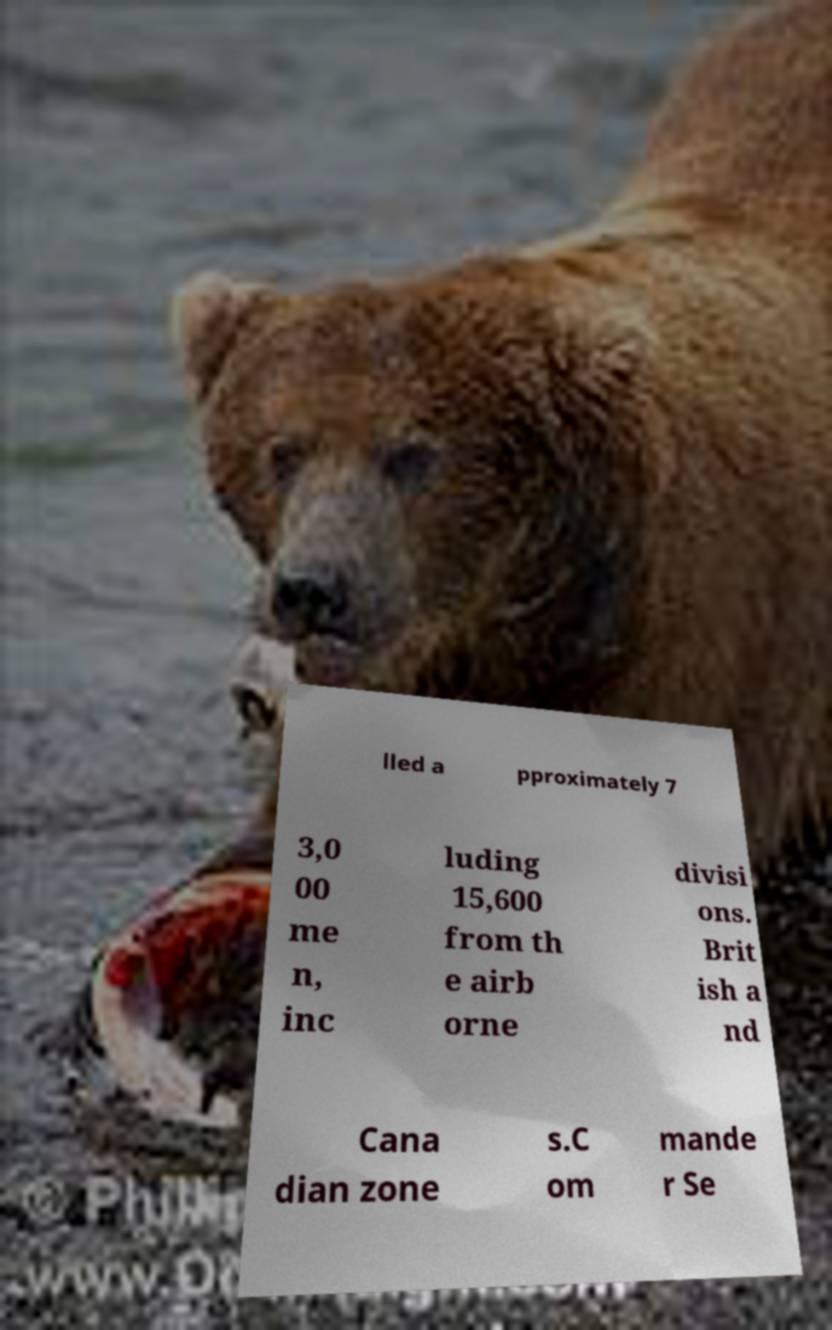Can you read and provide the text displayed in the image?This photo seems to have some interesting text. Can you extract and type it out for me? lled a pproximately 7 3,0 00 me n, inc luding 15,600 from th e airb orne divisi ons. Brit ish a nd Cana dian zone s.C om mande r Se 